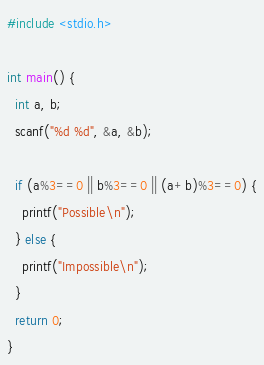Convert code to text. <code><loc_0><loc_0><loc_500><loc_500><_C_>#include <stdio.h>

int main() {
  int a, b;
  scanf("%d %d", &a, &b);

  if (a%3==0 || b%3==0 || (a+b)%3==0) {
    printf("Possible\n");
  } else {
    printf("Impossible\n");
  }
  return 0;
}</code> 